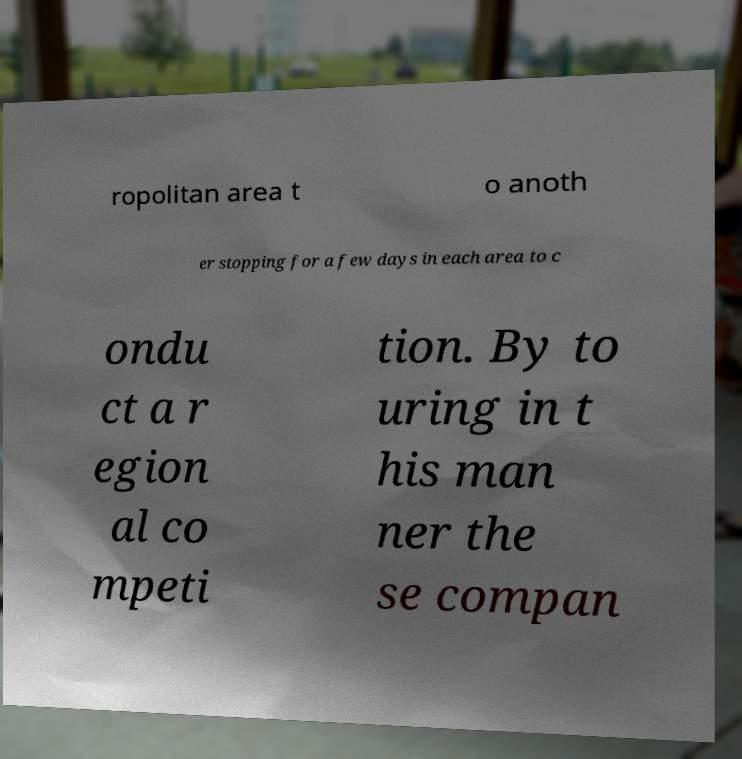Could you assist in decoding the text presented in this image and type it out clearly? ropolitan area t o anoth er stopping for a few days in each area to c ondu ct a r egion al co mpeti tion. By to uring in t his man ner the se compan 